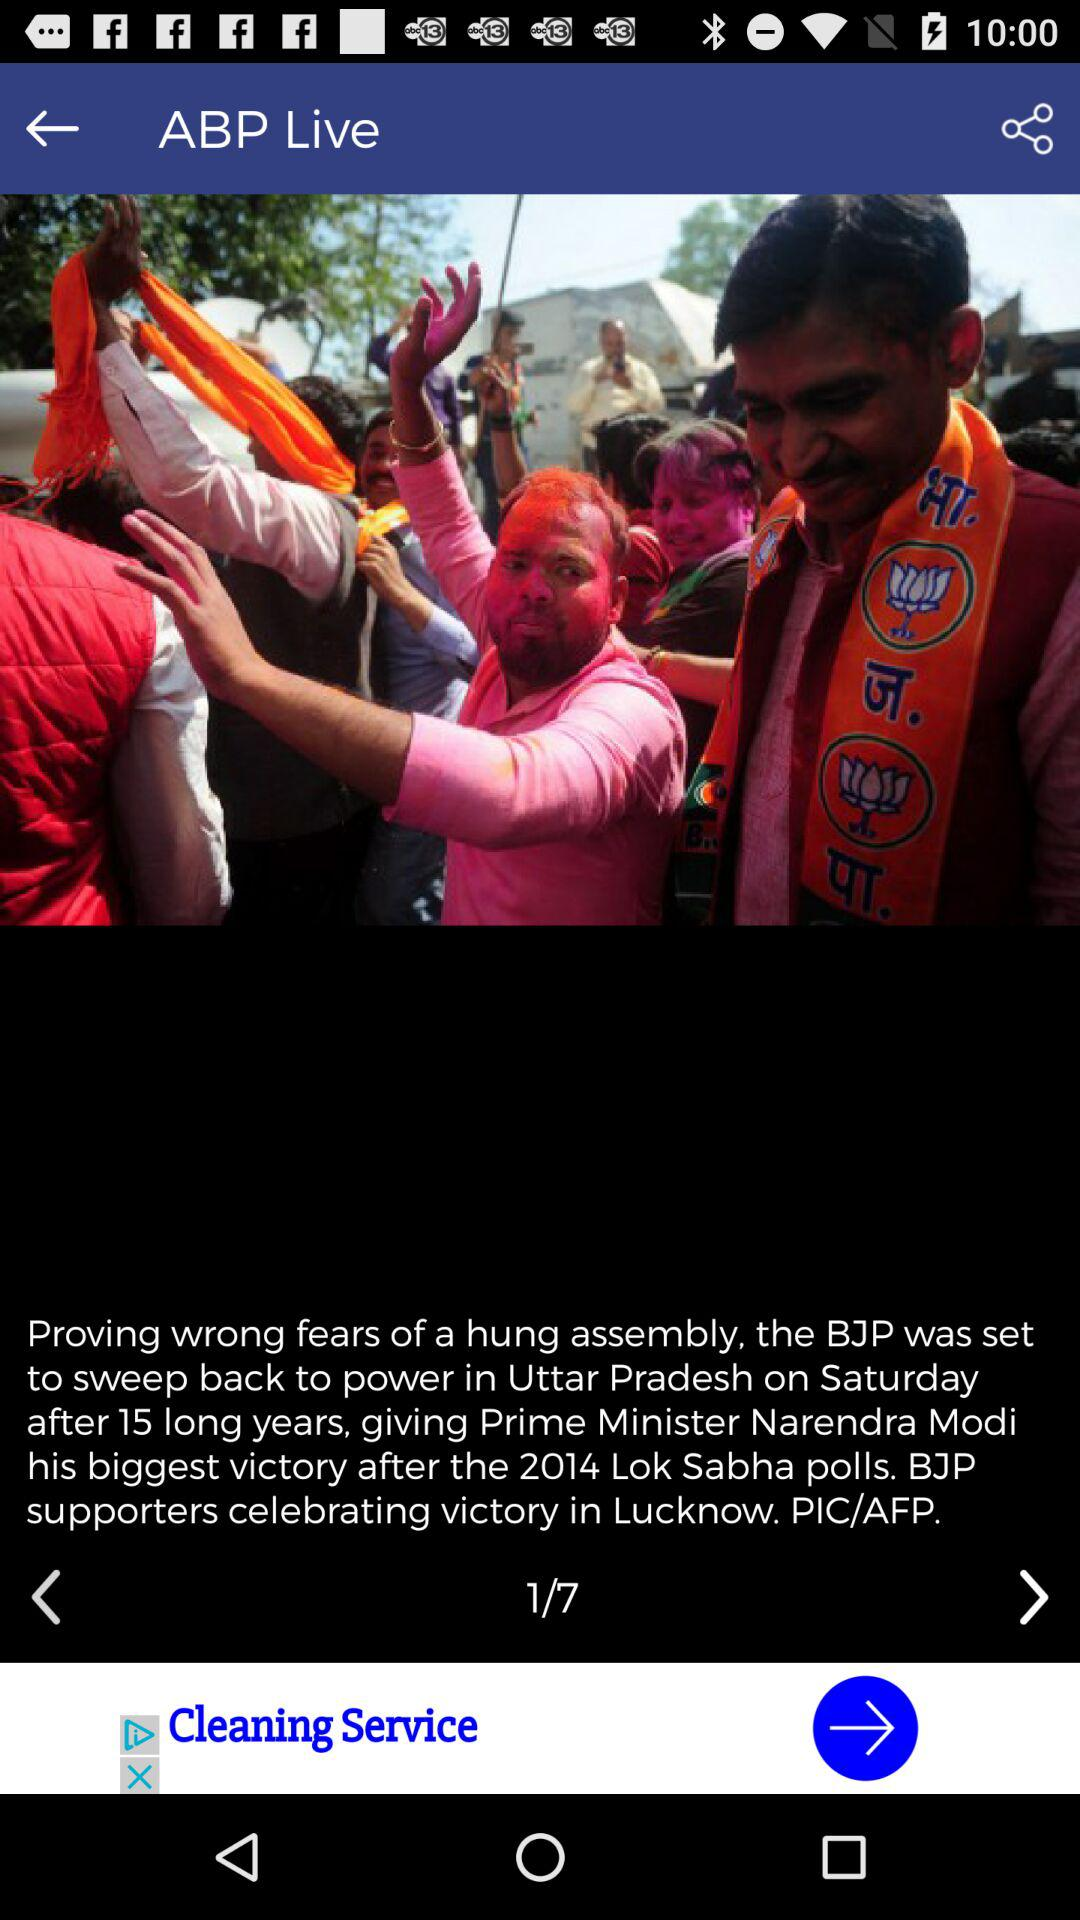On which page number is the user? The user is on page 1. 